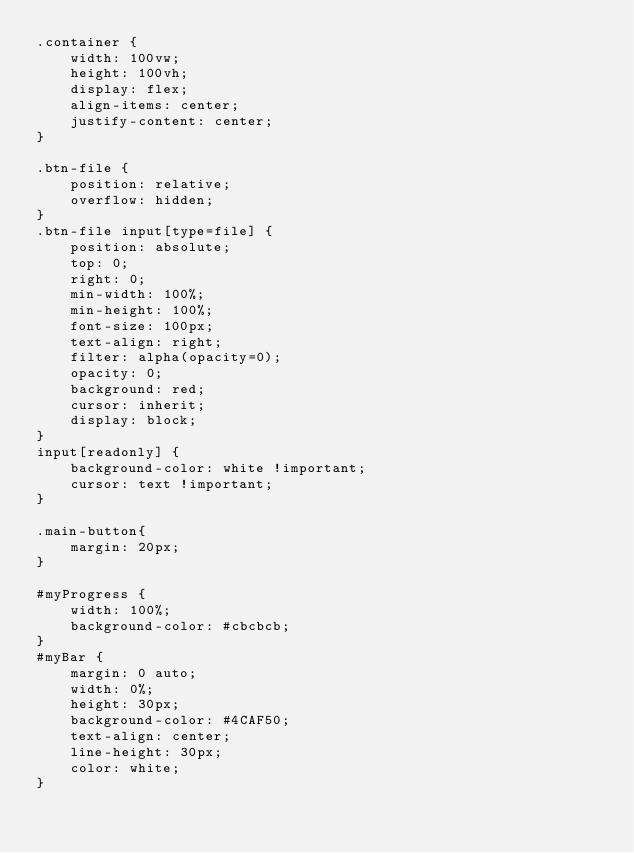Convert code to text. <code><loc_0><loc_0><loc_500><loc_500><_CSS_>.container {
    width: 100vw;
    height: 100vh;
    display: flex;
    align-items: center;
    justify-content: center;
}

.btn-file {
    position: relative;
    overflow: hidden;
}
.btn-file input[type=file] {
    position: absolute;
    top: 0;
    right: 0;
    min-width: 100%;
    min-height: 100%;
    font-size: 100px;
    text-align: right;
    filter: alpha(opacity=0);
    opacity: 0;
    background: red;
    cursor: inherit;
    display: block;
}
input[readonly] {
    background-color: white !important;
    cursor: text !important;
}

.main-button{
    margin: 20px;
}

#myProgress {
    width: 100%;
    background-color: #cbcbcb;
}
#myBar {
    margin: 0 auto;
    width: 0%;
    height: 30px;
    background-color: #4CAF50;
    text-align: center;
    line-height: 30px;
    color: white;
}</code> 